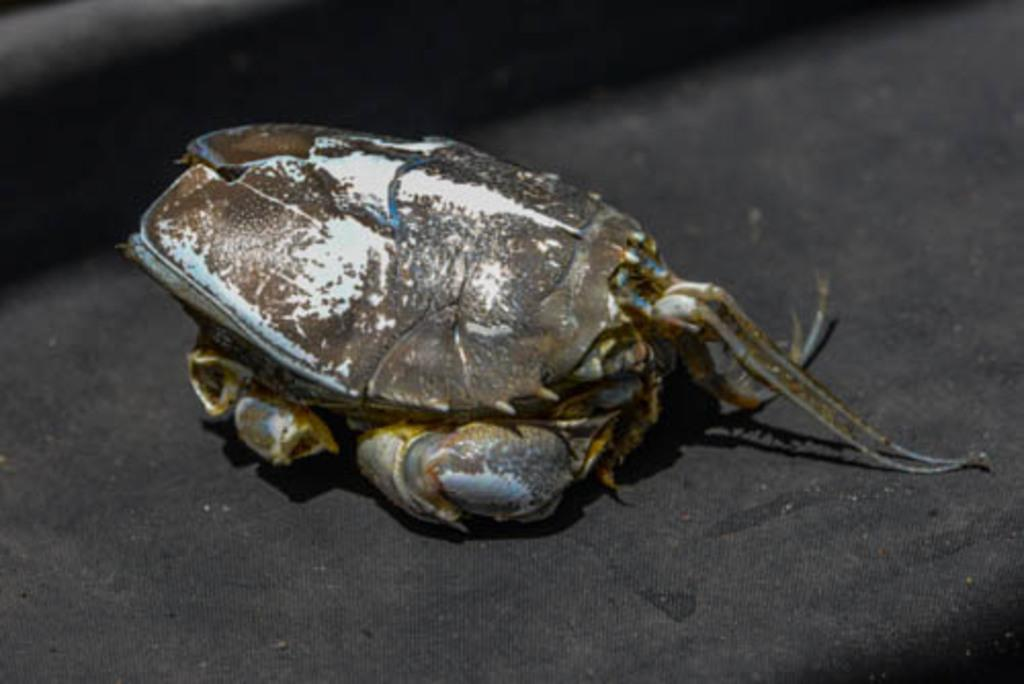What type of creature is in the image? There is an insect in the image. What colors can be seen on the insect? The insect has brown and white colors. What is the insect resting on in the image? The insect is on a black cloth. How many ducks are swimming in the water near the insect in the image? There are no ducks present in the image; it only features an insect on a black cloth. What type of locket is hanging from the insect's neck in the image? There is no locket present in the image; the insect is simply resting on a black cloth. 